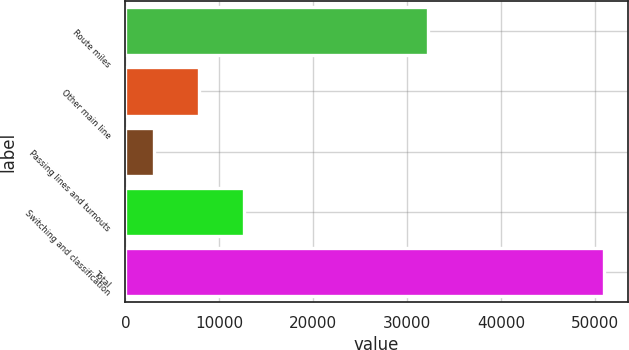<chart> <loc_0><loc_0><loc_500><loc_500><bar_chart><fcel>Route miles<fcel>Other main line<fcel>Passing lines and turnouts<fcel>Switching and classification<fcel>Total<nl><fcel>32205<fcel>7808.9<fcel>3021<fcel>12596.8<fcel>50900<nl></chart> 